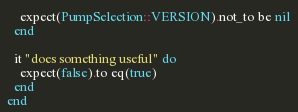Convert code to text. <code><loc_0><loc_0><loc_500><loc_500><_Ruby_>    expect(PumpSelection::VERSION).not_to be nil
  end

  it "does something useful" do
    expect(false).to eq(true)
  end
end
</code> 